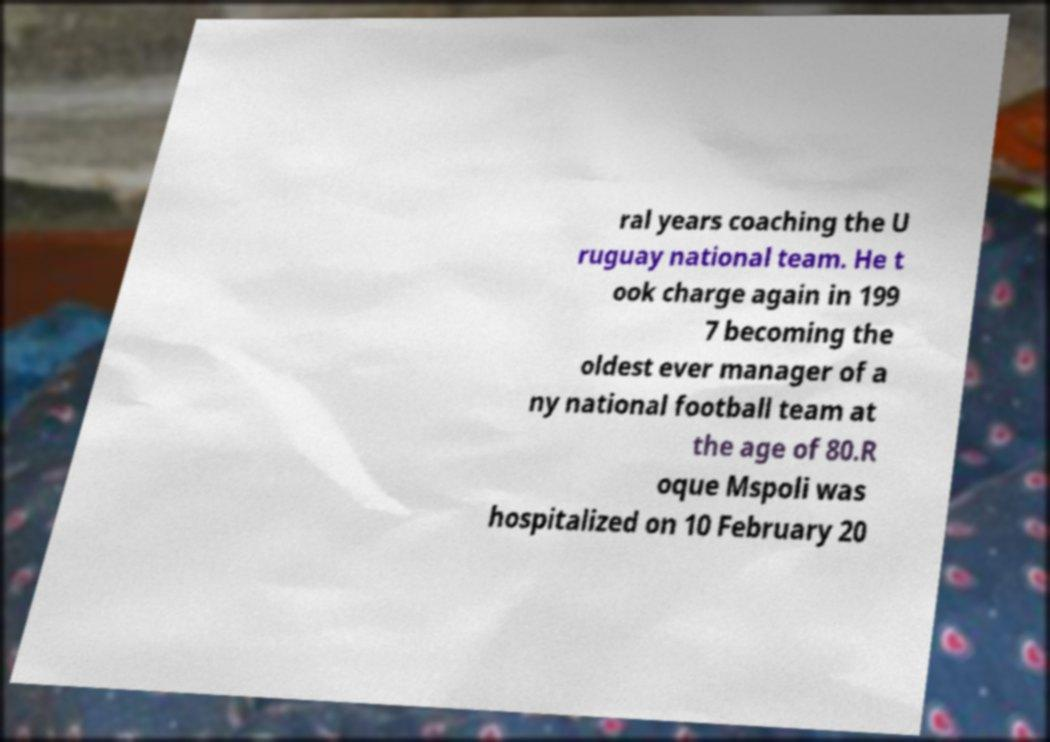Please identify and transcribe the text found in this image. ral years coaching the U ruguay national team. He t ook charge again in 199 7 becoming the oldest ever manager of a ny national football team at the age of 80.R oque Mspoli was hospitalized on 10 February 20 